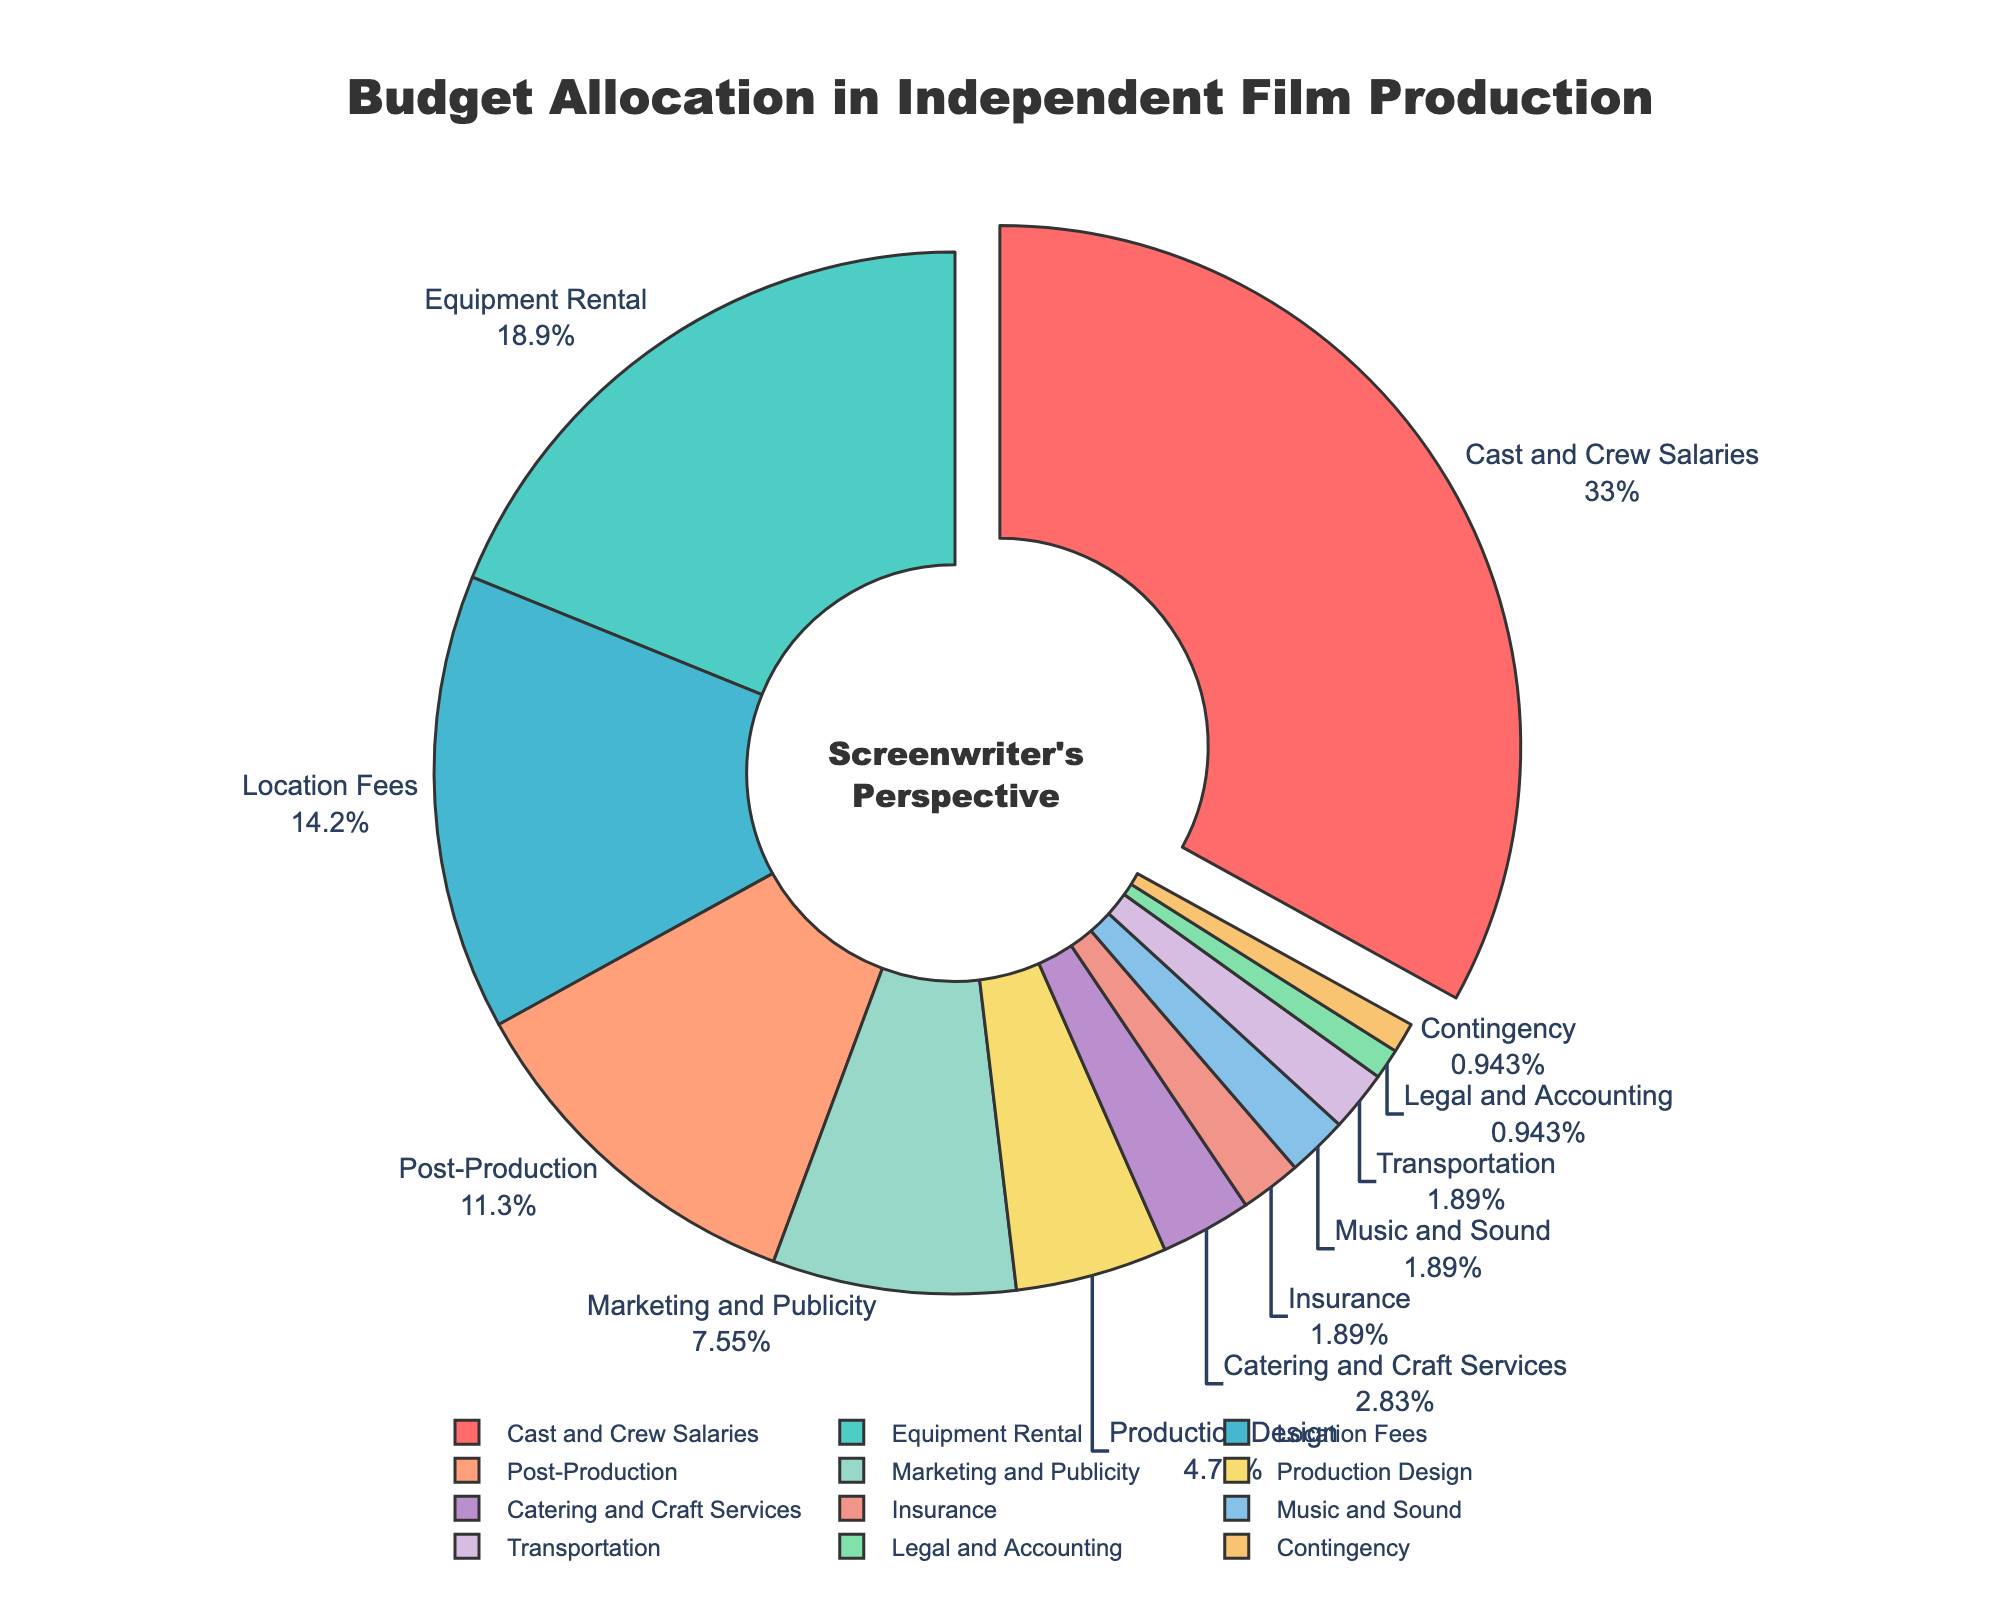What percentage of the total budget is allocated to Marketing and Publicity and Post-Production combined? Marketing and Publicity is 8% and Post-Production is 12%. Adding these together: 8% + 12% = 20%
Answer: 20% Which category has the highest budget allocation, and what is the percentage? The largest section of the pie chart is Cast and Crew Salaries, making it the category with the highest budget allocation at 35%.
Answer: Cast and Crew Salaries, 35% Are more funds allocated to Cast and Crew Salaries than Equipment Rental and Location Fees combined? Cast and Crew Salaries are allocated 35%. Equipment Rental and Location Fees together are 20% + 15% = 35%. Both are equal.
Answer: No What is the percentage difference between Catering and Craft Services and Production Design? Catering and Craft Services is 3% and Production Design is 5%. The difference is 5% - 3% = 2%.
Answer: 2% How much larger is the budget for Equipment Rental compared to Music and Sound? Equipment Rental is 20%, and Music and Sound is 2%. The difference is 20% - 2% = 18%.
Answer: 18% Which two categories have the smallest budget allocations, and what are their percentages? The smallest sections of the pie chart are Legal and Accounting, and Contingency, each with 1%.
Answer: Legal and Accounting, Contingency, 1% Is the combined budget for Insurance and Transportation greater than Marketing and Publicity? Insurance is 2% and Transportation is 2%. Combined, they are 2% + 2% = 4%. Marketing and Publicity is 8%, which is greater than 4%.
Answer: No What is the visual difference in the pie chart between the largest and smallest budget categories? The largest category, Cast and Crew Salaries, has a significantly larger slice compared to the smallest categories like Legal and Accounting or Contingency which have very thin slices.
Answer: A large portion vs very thin slices How do the budget allocations for Production Design and Catering and Craft Services together compare to Cast and Crew Salaries? Production Design is 5% and Catering and Craft Services is 3%. Together, they make 5% + 3% = 8%, which is much smaller than Cast and Crew Salaries at 35%.
Answer: Much smaller 